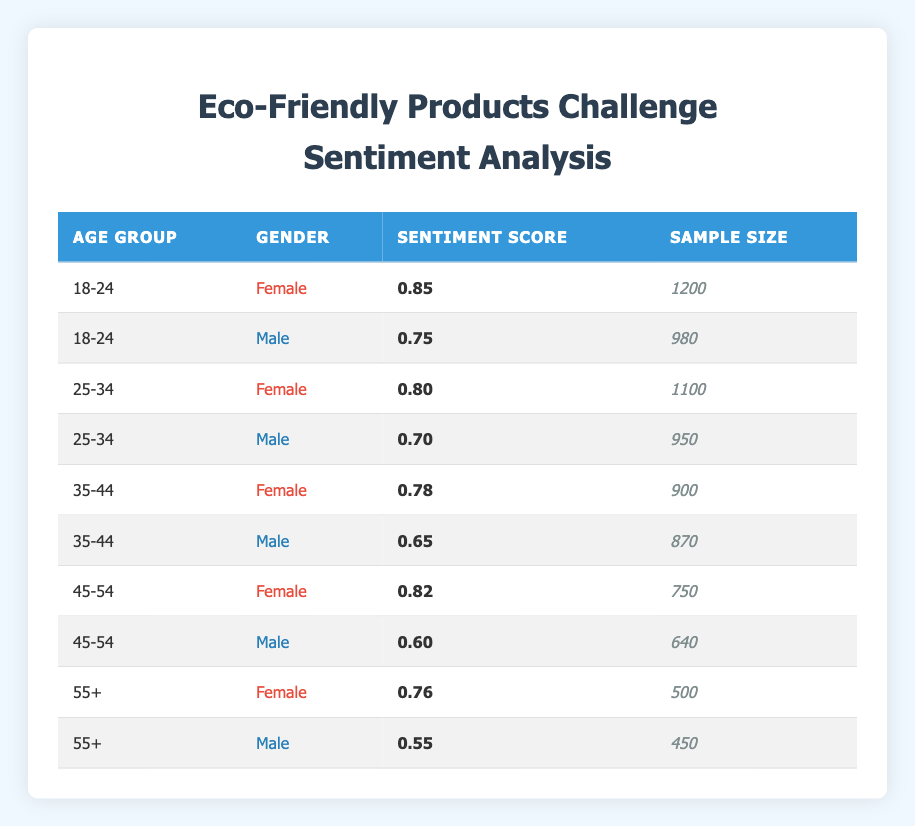What is the sentiment score for 18-24 year old females? The table clearly shows the row for females in the 18-24 age group, which indicates a sentiment score of 0.85.
Answer: 0.85 What is the sample size for 55+ year old males? The table includes the row for males in the 55+ age group, which lists a sample size of 450.
Answer: 450 Which gender in the 25-34 age group has a higher sentiment score? The sentiment scores for females and males in the 25-34 age group are 0.80 and 0.70, respectively. Since 0.80 is greater than 0.70, females have a higher sentiment score.
Answer: Female What is the average sentiment score for males across all age groups? The sentiment scores for males are 0.75 (18-24), 0.70 (25-34), 0.65 (35-44), 0.60 (45-54), and 0.55 (55+). Summing these gives 0.75 + 0.70 + 0.65 + 0.60 + 0.55 = 3.95. Dividing by the number of age groups (5) gives an average of 3.95 / 5 = 0.79.
Answer: 0.79 Is the sentiment score for 45-54 year old females higher than that for 35-44 year old females? The sentiment score for females in the 45-54 age group is 0.82, while for 35-44 year old females it is 0.78. Since 0.82 is greater than 0.78, the statement is true.
Answer: Yes What is the difference in sentiment scores between 18-24 year old males and females? The sentiment score for 18-24 year old females is 0.85, and for males, it is 0.75. The difference is calculated by subtracting the male score from the female score: 0.85 - 0.75 = 0.10.
Answer: 0.10 Which age group has the highest sentiment score for females? Reviewing the table, the age groups for females show scores of 0.85 (18-24), 0.80 (25-34), 0.78 (35-44), 0.82 (45-54), and 0.76 (55+). The highest among these is 0.85 for the 18-24 age group.
Answer: 18-24 Is the sample size for 45-54 year old males greater than that for 35-44 year old males? The sample sizes are 640 for 45-54 year old males and 870 for 35-44 year old males. Since 640 is less than 870, the statement is false.
Answer: No 